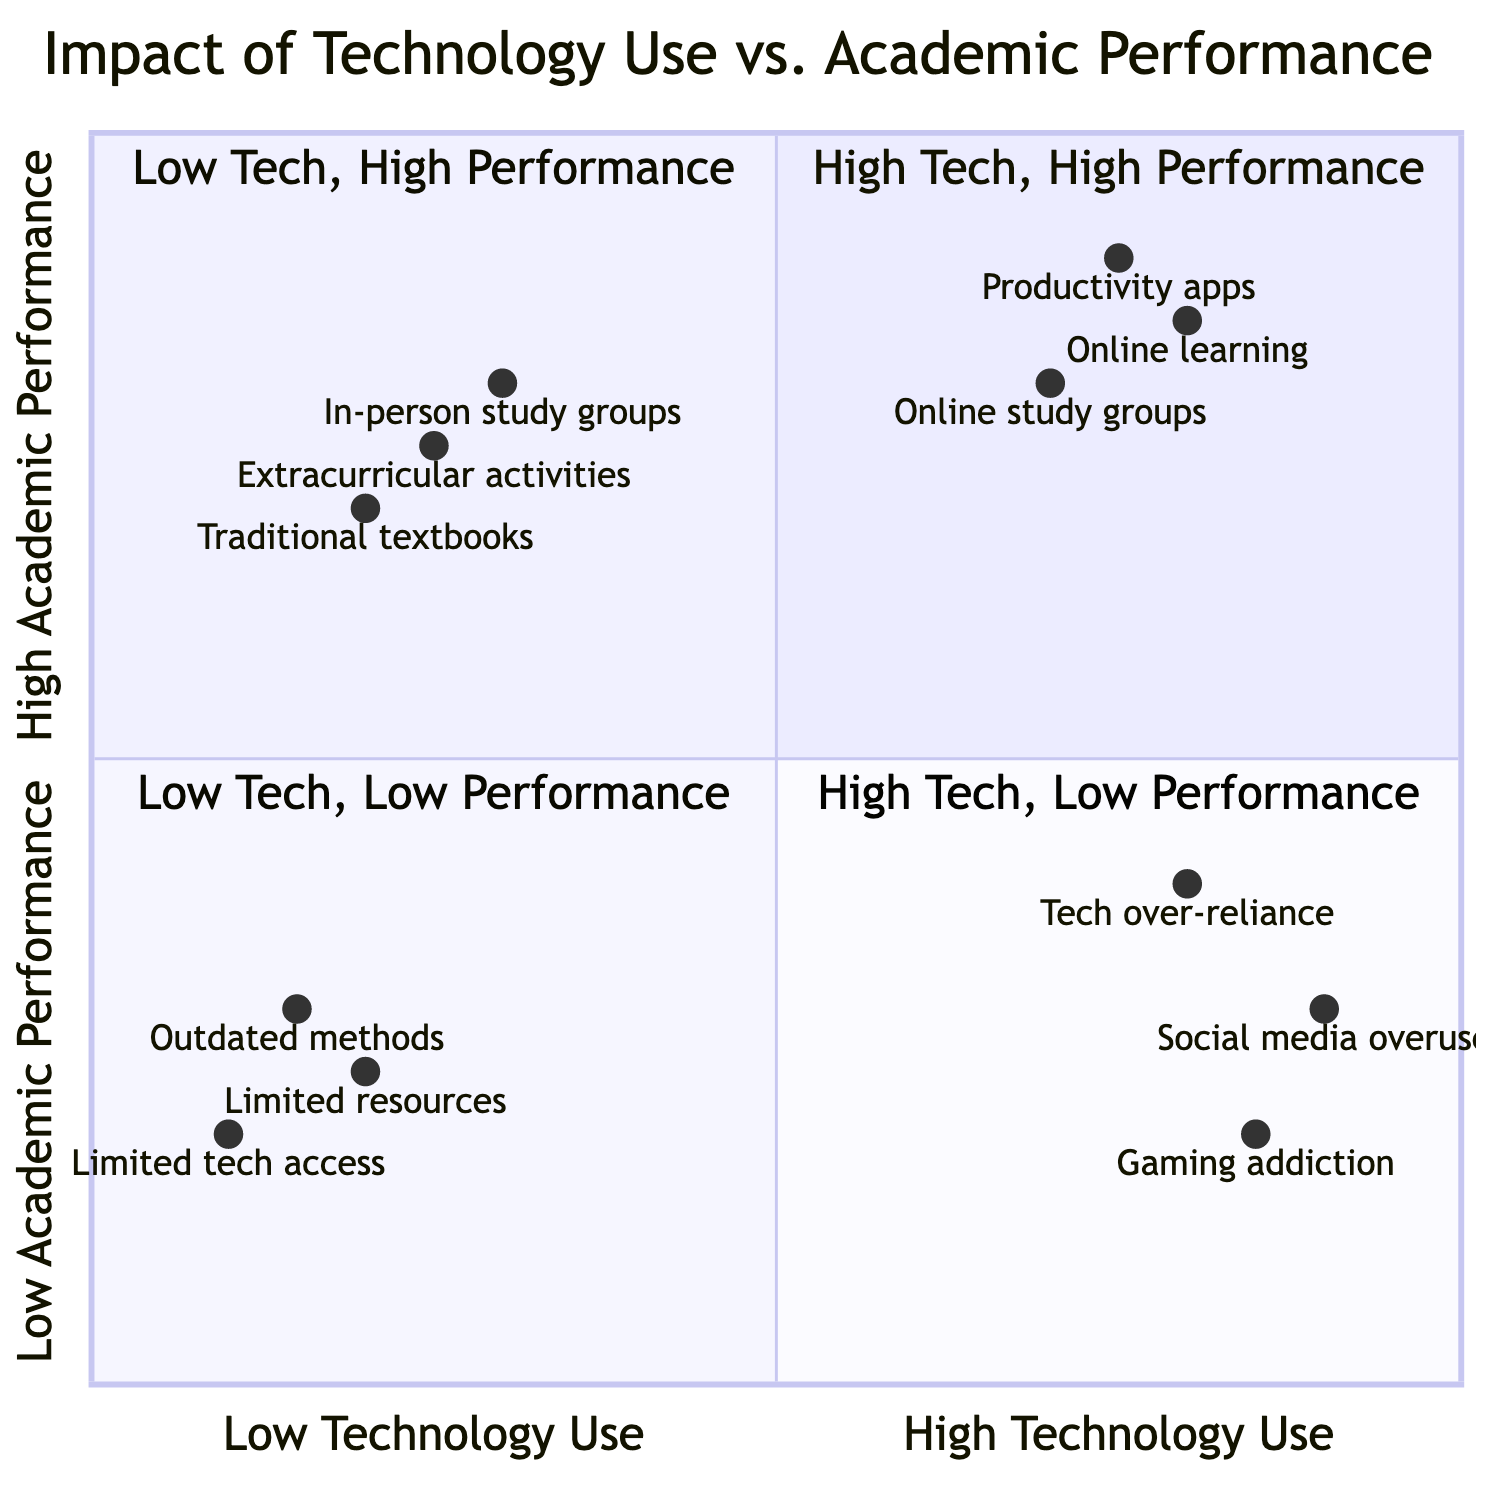What examples are in the "High Technology Use, High Academic Performance" quadrant? This quadrant includes students using online learning platforms like Coursera or Khan Academy, using productivity apps such as Notion for organizing study schedules, and participating in online study groups and forums.
Answer: Online learning platforms, productivity apps, online study groups What benefits are associated with "Low Technology Use, High Academic Performance"? The benefits listed in this quadrant are deep focus and critical thinking, stronger personal interactions and communication skills, and improved hands-on and practical knowledge.
Answer: Deep focus, stronger personal interactions, improved hands-on knowledge How many examples are listed in the "High Technology Use, Low Academic Performance" quadrant? There are three examples provided in this quadrant: excessive social media use, gaming addiction, and tech over-reliance.
Answer: 3 Which quadrant has the least engagement according to the challenges listed? The "Low Technology Use, Low Academic Performance" quadrant is indicated to have limited access to updated information and resources, reduced competitiveness in tech-driven environments, and lower engagement and motivation, thus showing least engagement.
Answer: Low Technology Use, Low Academic Performance What is the highest score for a given technology use in "Low Technology Use, High Academic Performance"? Referring to the diagram, the highest score for any example in this quadrant is 0.3 for in-person study groups.
Answer: 0.3 What challenges are found in the "High Technology Use, Low Academic Performance" quadrant? The challenges in this quadrant include distraction and reduced focus on studies, poor time management, and reduced face-to-face social interactions and communication skills.
Answer: Distraction, poor time management, reduced social interactions Which examples demonstrate a reliance on outdated methods? The examples showing reliance on outdated methods include lack of access to modern educational tools and resources, limited exposure to diverse learning materials, and dependence on outdated teaching methods.
Answer: Lack of access, limited exposure, outdated methods What is the relationship between high technology use and academic performance in the fourth quadrant? In the fourth quadrant, the relationship indicates that high technology use correlates with low academic performance, primarily due to distractions and poor focus.
Answer: High Technology Use, Low Academic Performance How does the "Low Technology Use, Low Academic Performance" quadrant compare with "High Technology Use, High Academic Performance"? The former quadrant shows limited access and reduced competitiveness, while the latter quadrant highlights enhanced collaboration and access to extensive knowledge, indicating a significant performance gap.
Answer: Limited access vs. enhanced collaboration 